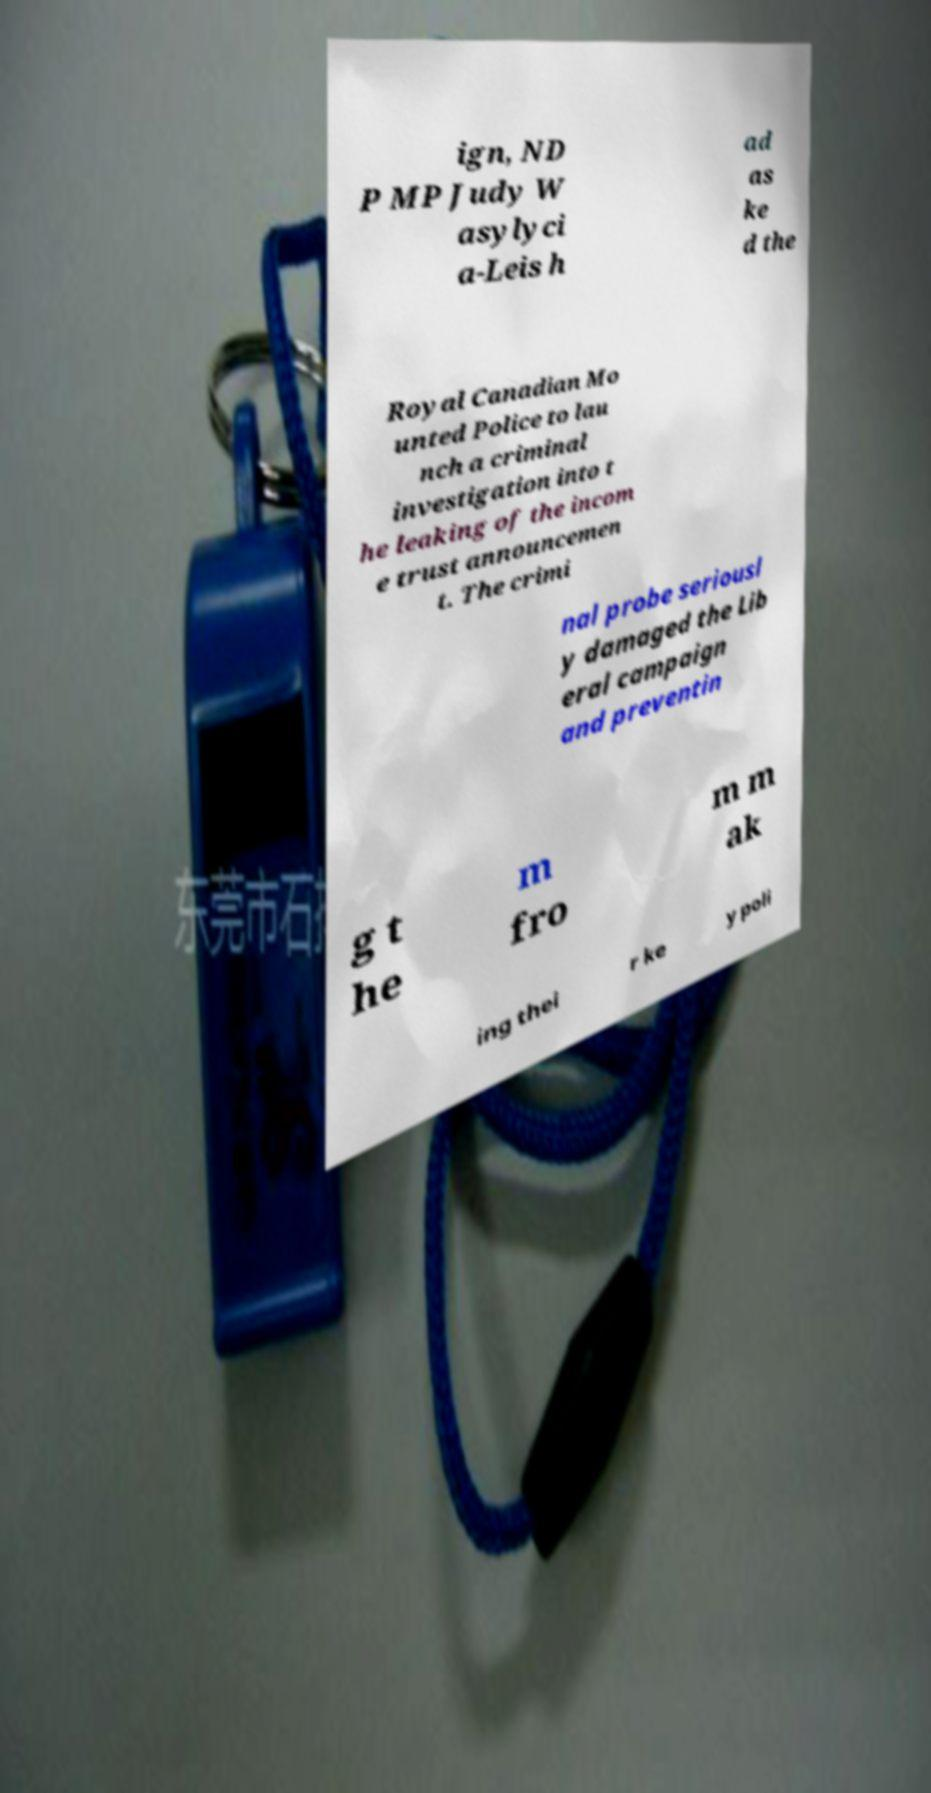Can you accurately transcribe the text from the provided image for me? ign, ND P MP Judy W asylyci a-Leis h ad as ke d the Royal Canadian Mo unted Police to lau nch a criminal investigation into t he leaking of the incom e trust announcemen t. The crimi nal probe seriousl y damaged the Lib eral campaign and preventin g t he m fro m m ak ing thei r ke y poli 